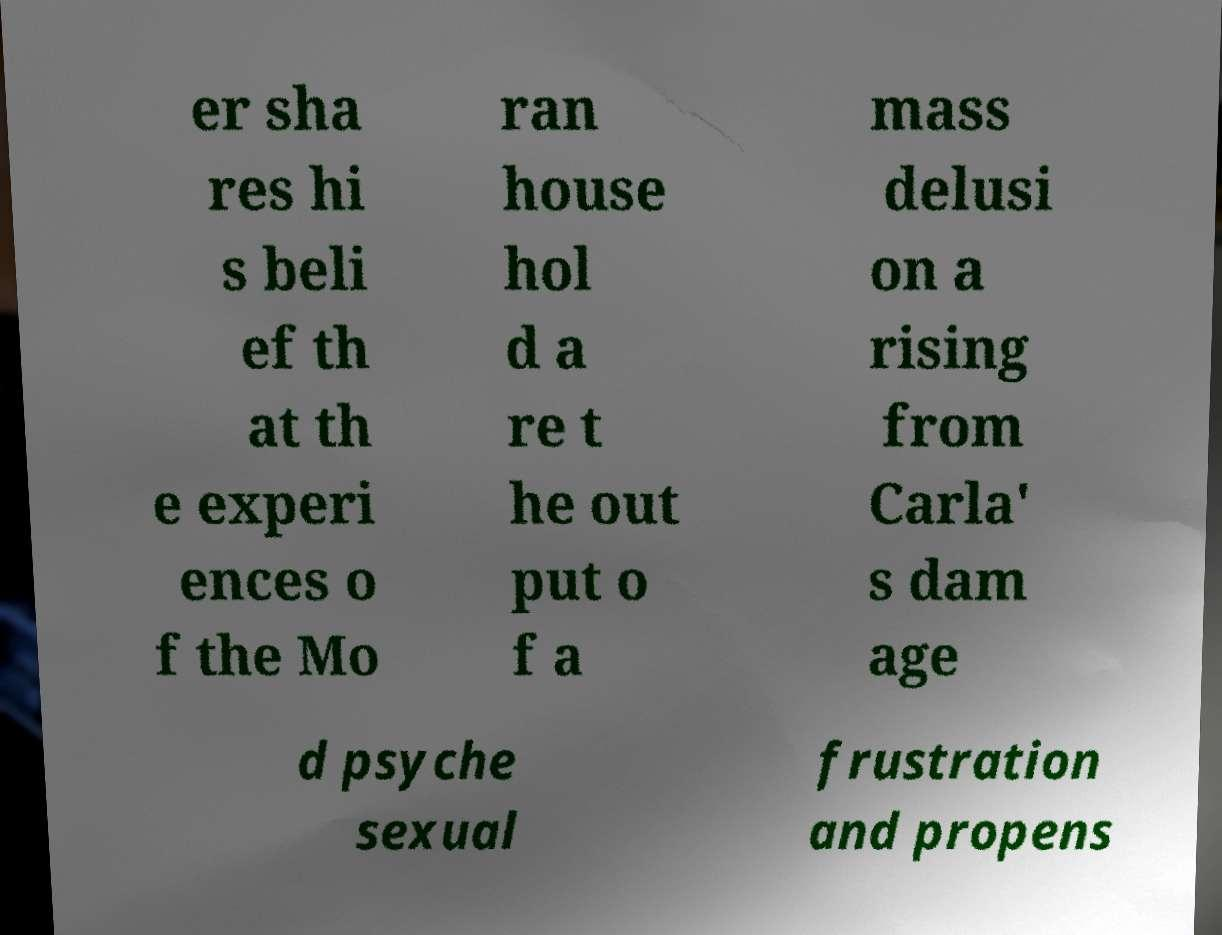What messages or text are displayed in this image? I need them in a readable, typed format. er sha res hi s beli ef th at th e experi ences o f the Mo ran house hol d a re t he out put o f a mass delusi on a rising from Carla' s dam age d psyche sexual frustration and propens 